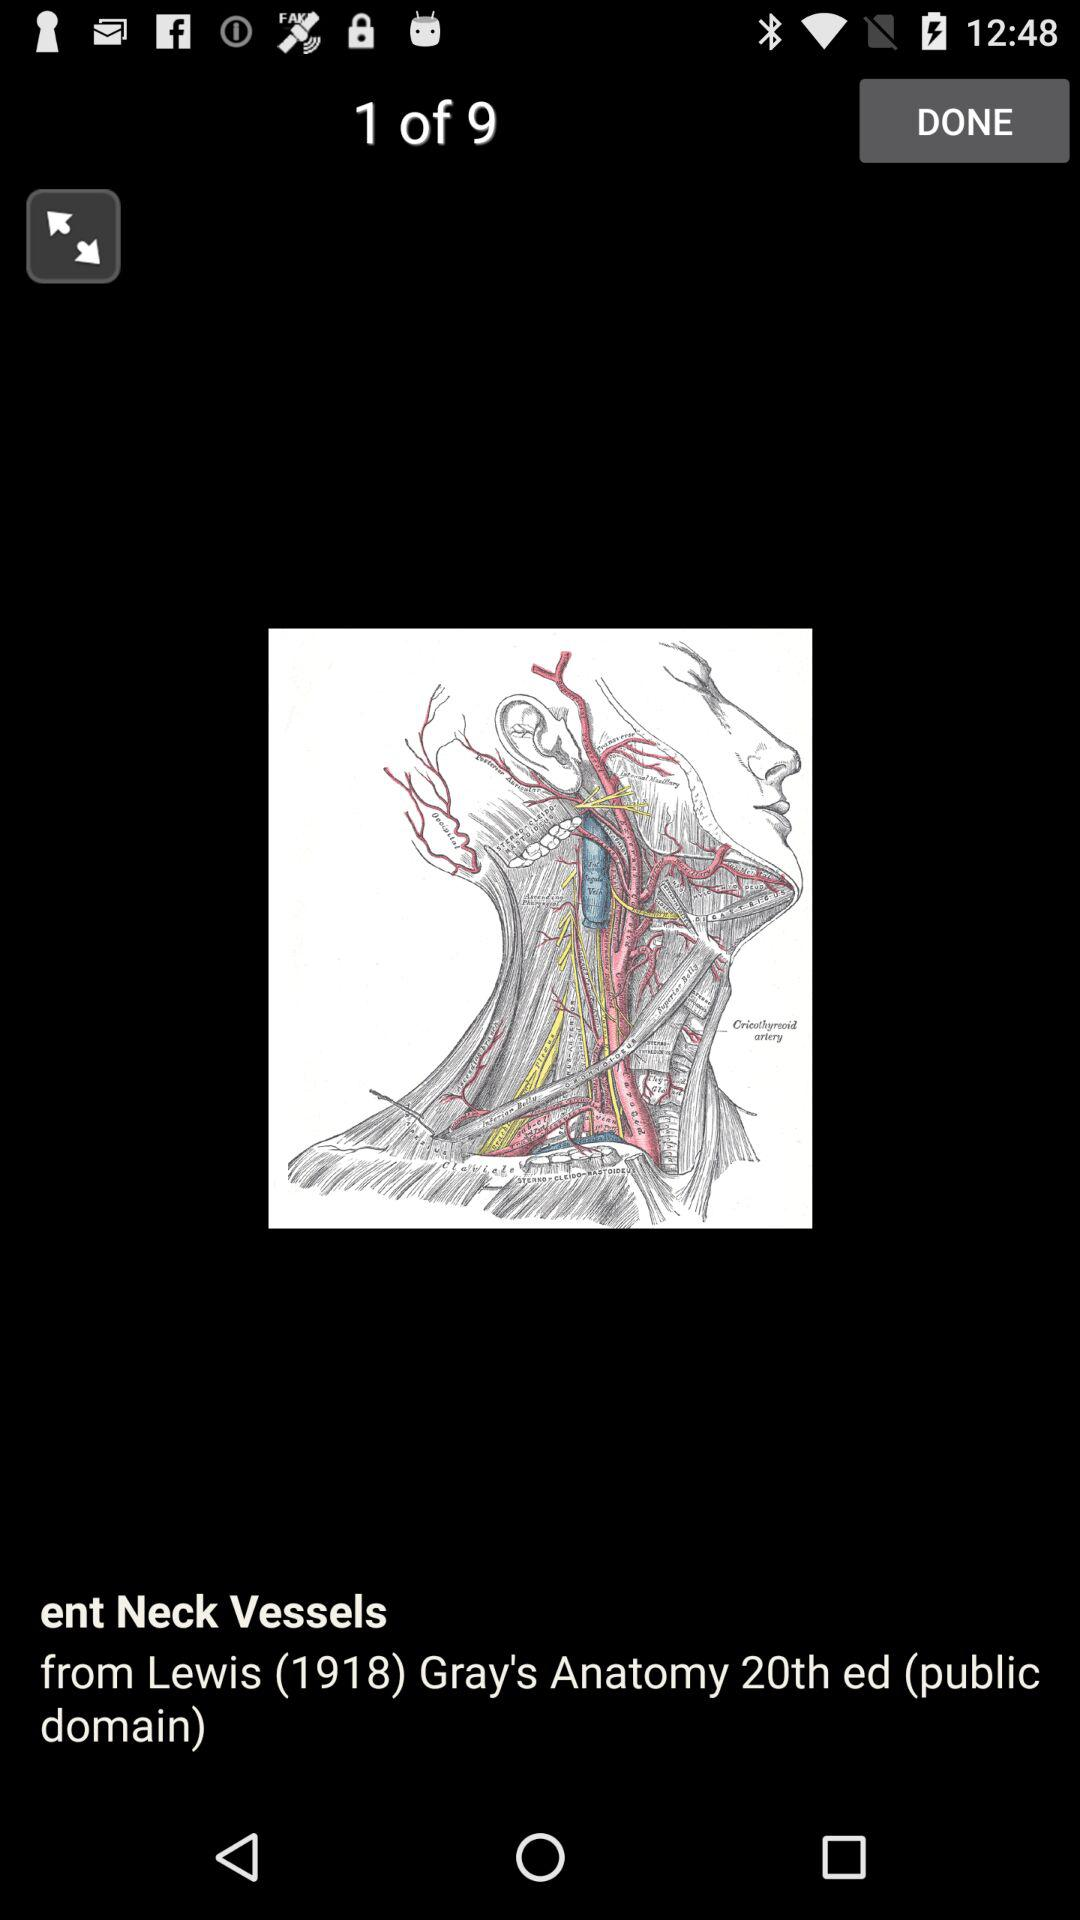On which image am I now? You are on image 1. 